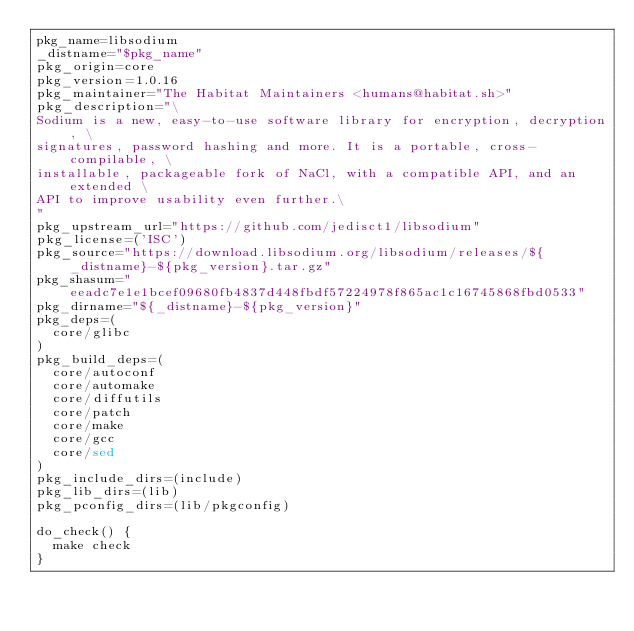Convert code to text. <code><loc_0><loc_0><loc_500><loc_500><_Bash_>pkg_name=libsodium
_distname="$pkg_name"
pkg_origin=core
pkg_version=1.0.16
pkg_maintainer="The Habitat Maintainers <humans@habitat.sh>"
pkg_description="\
Sodium is a new, easy-to-use software library for encryption, decryption, \
signatures, password hashing and more. It is a portable, cross-compilable, \
installable, packageable fork of NaCl, with a compatible API, and an extended \
API to improve usability even further.\
"
pkg_upstream_url="https://github.com/jedisct1/libsodium"
pkg_license=('ISC')
pkg_source="https://download.libsodium.org/libsodium/releases/${_distname}-${pkg_version}.tar.gz"
pkg_shasum="eeadc7e1e1bcef09680fb4837d448fbdf57224978f865ac1c16745868fbd0533"
pkg_dirname="${_distname}-${pkg_version}"
pkg_deps=(
  core/glibc
)
pkg_build_deps=(
  core/autoconf
  core/automake
  core/diffutils
  core/patch
  core/make
  core/gcc
  core/sed
)
pkg_include_dirs=(include)
pkg_lib_dirs=(lib)
pkg_pconfig_dirs=(lib/pkgconfig)

do_check() {
  make check
}
</code> 